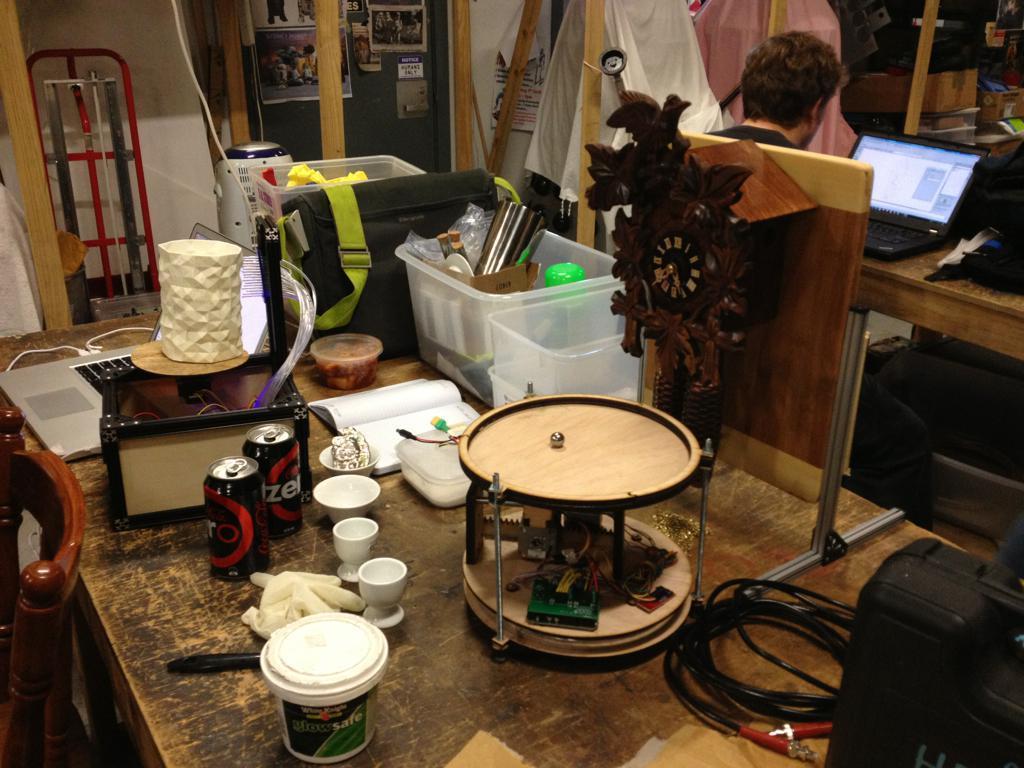Describe this image in one or two sentences. In the image we can see a person wearing clothes and the person is sitting on the chair. In front of the person there is a table, on the table, we can see a laptop and other objects. Here we can see a wooden surface, on it we can see a bucket, bowls, cans, cable wires, box, a book, plastic container, bag, tissue roll and other things. Here we can see a stand, posters and wooden poles. 